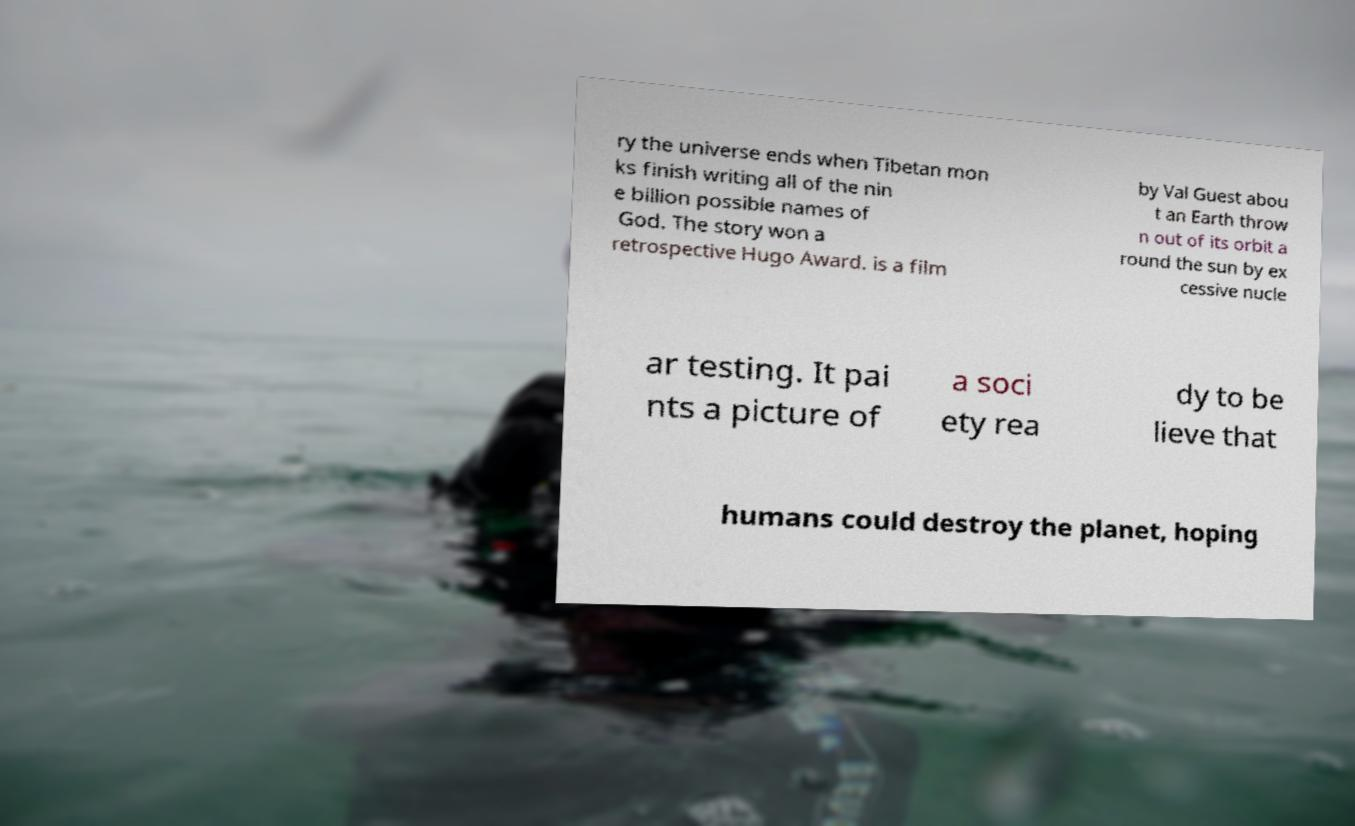For documentation purposes, I need the text within this image transcribed. Could you provide that? ry the universe ends when Tibetan mon ks finish writing all of the nin e billion possible names of God. The story won a retrospective Hugo Award. is a film by Val Guest abou t an Earth throw n out of its orbit a round the sun by ex cessive nucle ar testing. It pai nts a picture of a soci ety rea dy to be lieve that humans could destroy the planet, hoping 